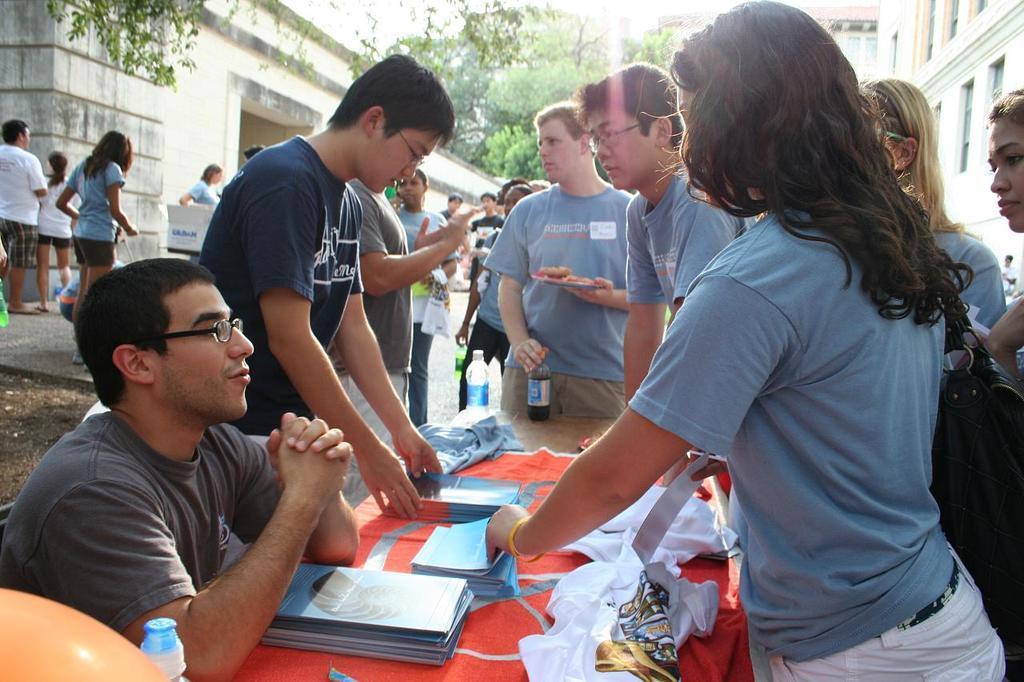How would you summarize this image in a sentence or two? In this image there are a group of people standing around a table and talking with each other, on the table there are a few pamphlets and a few other objects, in front of the image there is a person sitting in front of the table, in the background of the image there are few other people standing and walking and there are trees and buildings. 